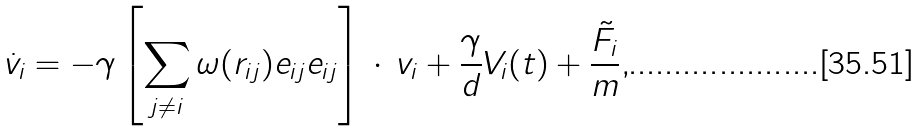Convert formula to latex. <formula><loc_0><loc_0><loc_500><loc_500>\dot { v } _ { i } = - \gamma \left [ \sum _ { j \neq i } \omega ( r _ { i j } ) { e } _ { i j } { e } _ { i j } \right ] \, \cdot \, { v } _ { i } + \frac { \gamma } { d } { V } _ { i } ( t ) + \frac { \tilde { F } _ { i } } { m } ,</formula> 